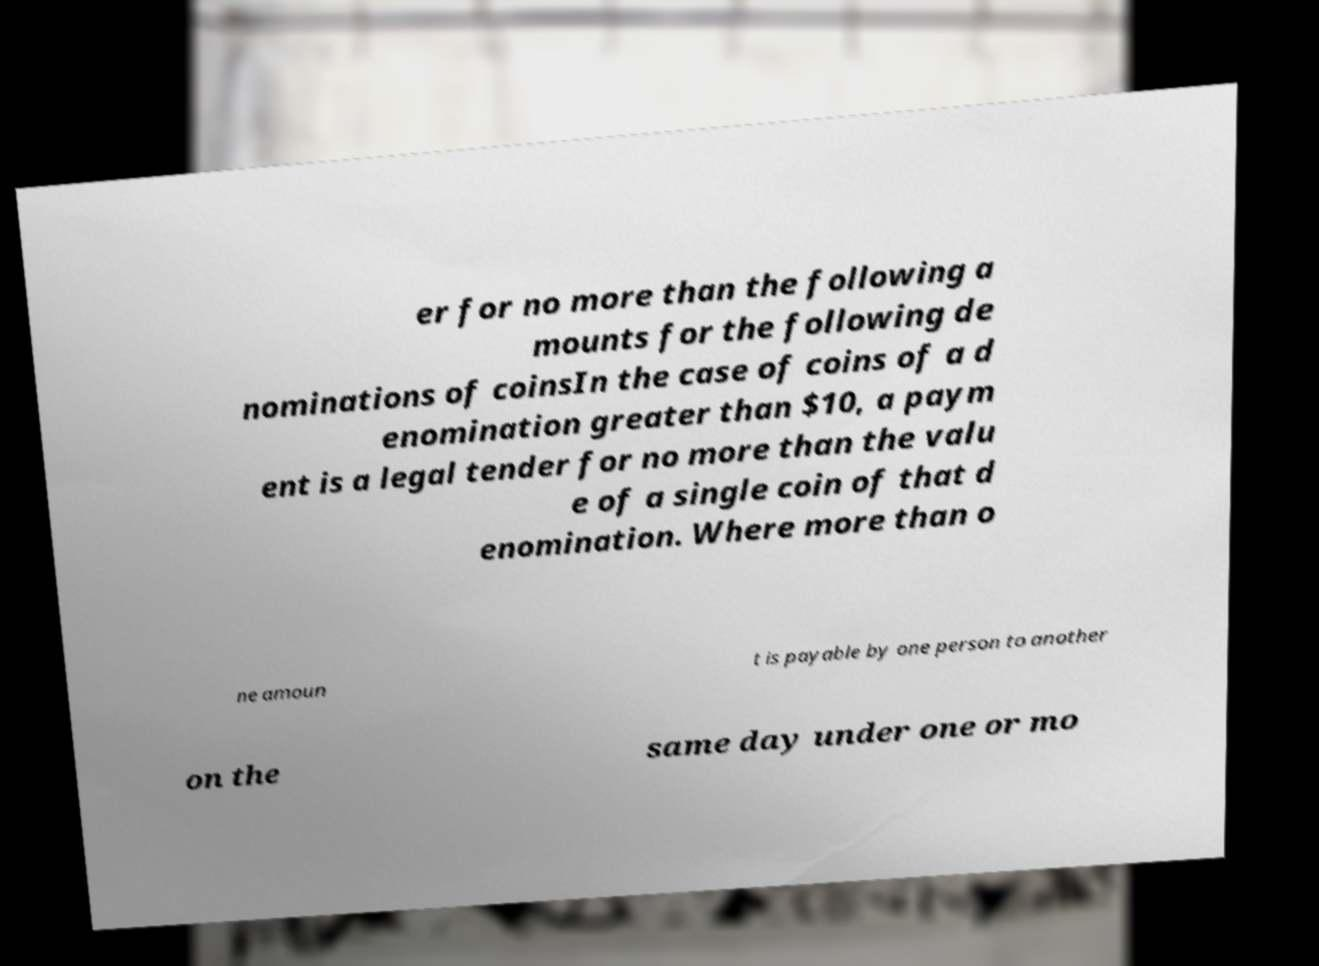Could you extract and type out the text from this image? er for no more than the following a mounts for the following de nominations of coinsIn the case of coins of a d enomination greater than $10, a paym ent is a legal tender for no more than the valu e of a single coin of that d enomination. Where more than o ne amoun t is payable by one person to another on the same day under one or mo 